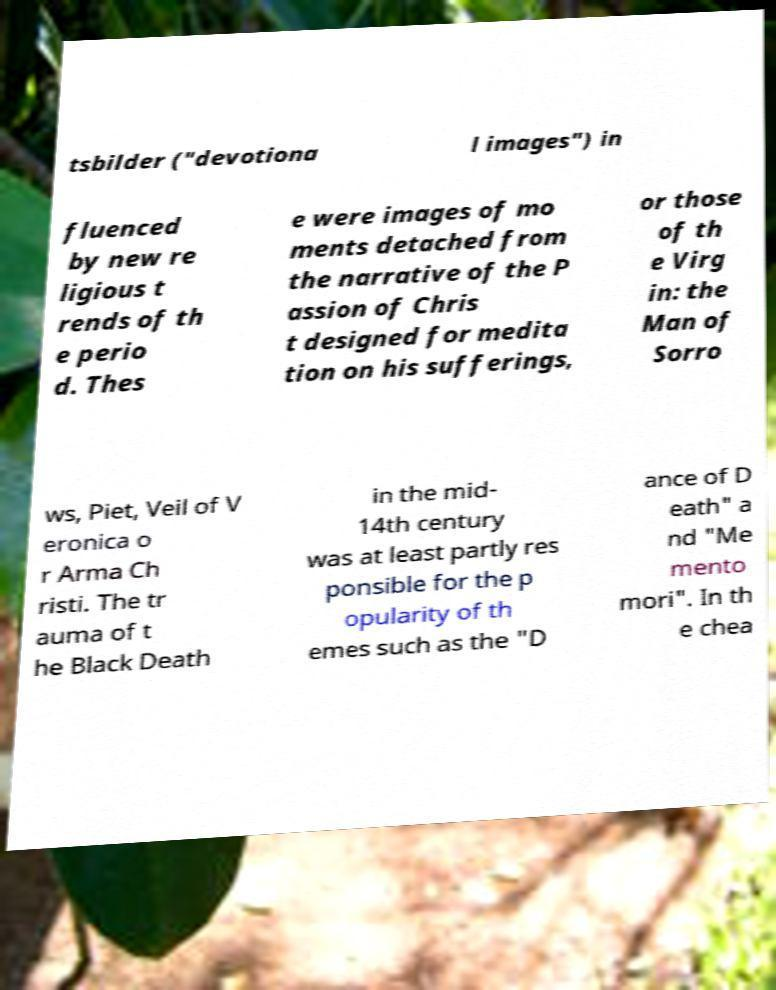Could you extract and type out the text from this image? tsbilder ("devotiona l images") in fluenced by new re ligious t rends of th e perio d. Thes e were images of mo ments detached from the narrative of the P assion of Chris t designed for medita tion on his sufferings, or those of th e Virg in: the Man of Sorro ws, Piet, Veil of V eronica o r Arma Ch risti. The tr auma of t he Black Death in the mid- 14th century was at least partly res ponsible for the p opularity of th emes such as the "D ance of D eath" a nd "Me mento mori". In th e chea 